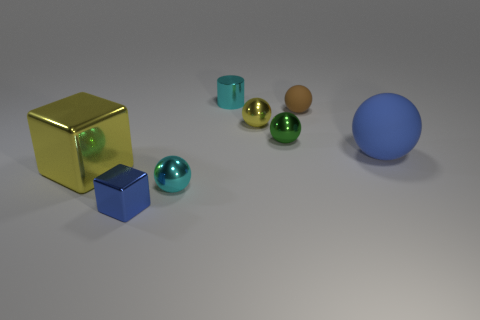The small sphere that is left of the small green ball and behind the green shiny sphere is made of what material?
Offer a terse response. Metal. Do the sphere to the left of the cyan cylinder and the large blue ball have the same size?
Keep it short and to the point. No. What is the big blue object made of?
Offer a very short reply. Rubber. There is a cube that is behind the tiny cyan shiny sphere; what is its color?
Make the answer very short. Yellow. What number of big things are either matte spheres or cylinders?
Make the answer very short. 1. Do the metal ball that is behind the tiny green thing and the big object that is to the left of the brown rubber thing have the same color?
Provide a short and direct response. Yes. What number of other objects are the same color as the tiny cube?
Keep it short and to the point. 1. What number of green objects are small metallic spheres or small metallic things?
Give a very brief answer. 1. There is a tiny brown rubber object; is it the same shape as the cyan object that is behind the yellow metallic block?
Your answer should be compact. No. The large matte object is what shape?
Keep it short and to the point. Sphere. 